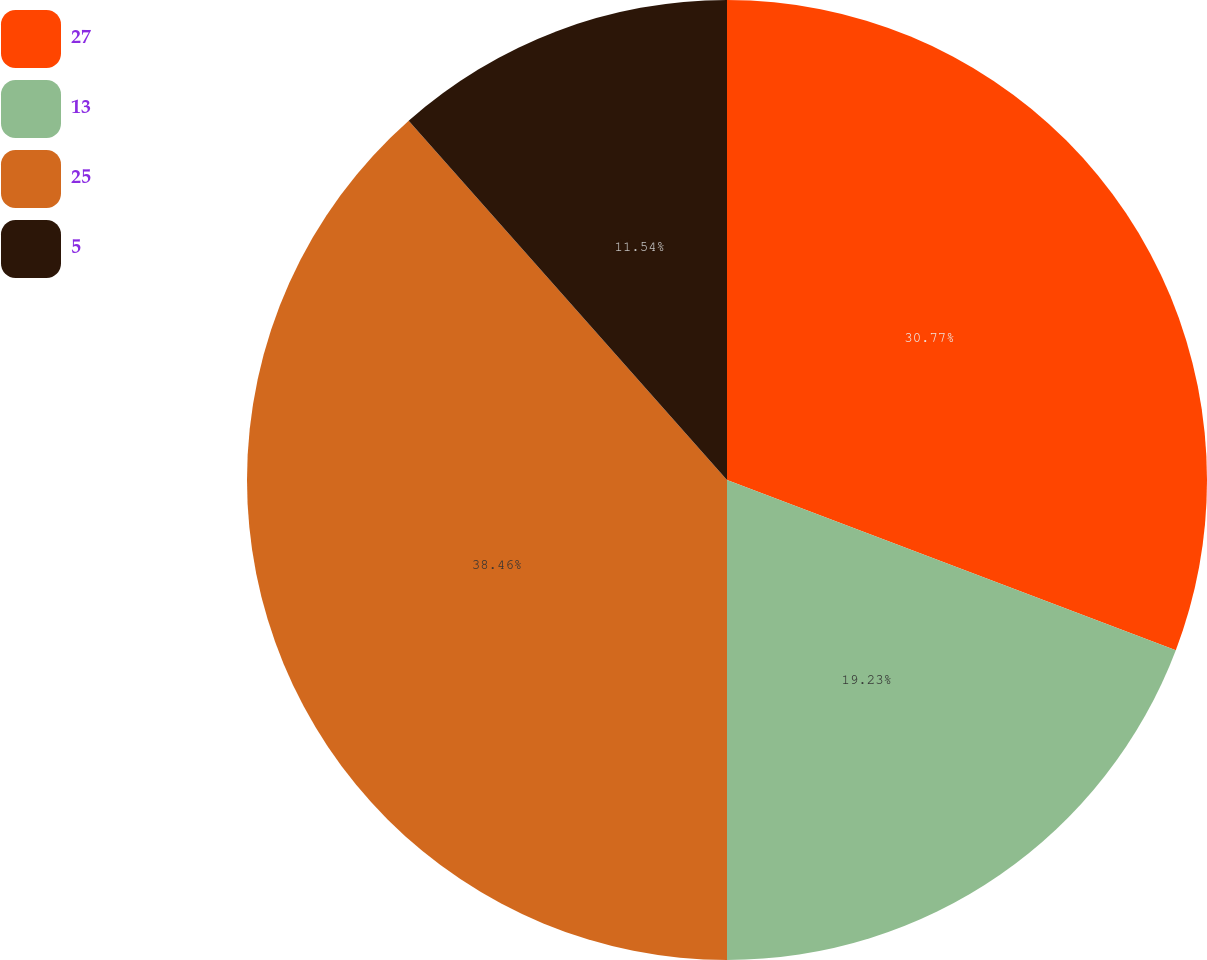<chart> <loc_0><loc_0><loc_500><loc_500><pie_chart><fcel>27<fcel>13<fcel>25<fcel>5<nl><fcel>30.77%<fcel>19.23%<fcel>38.46%<fcel>11.54%<nl></chart> 